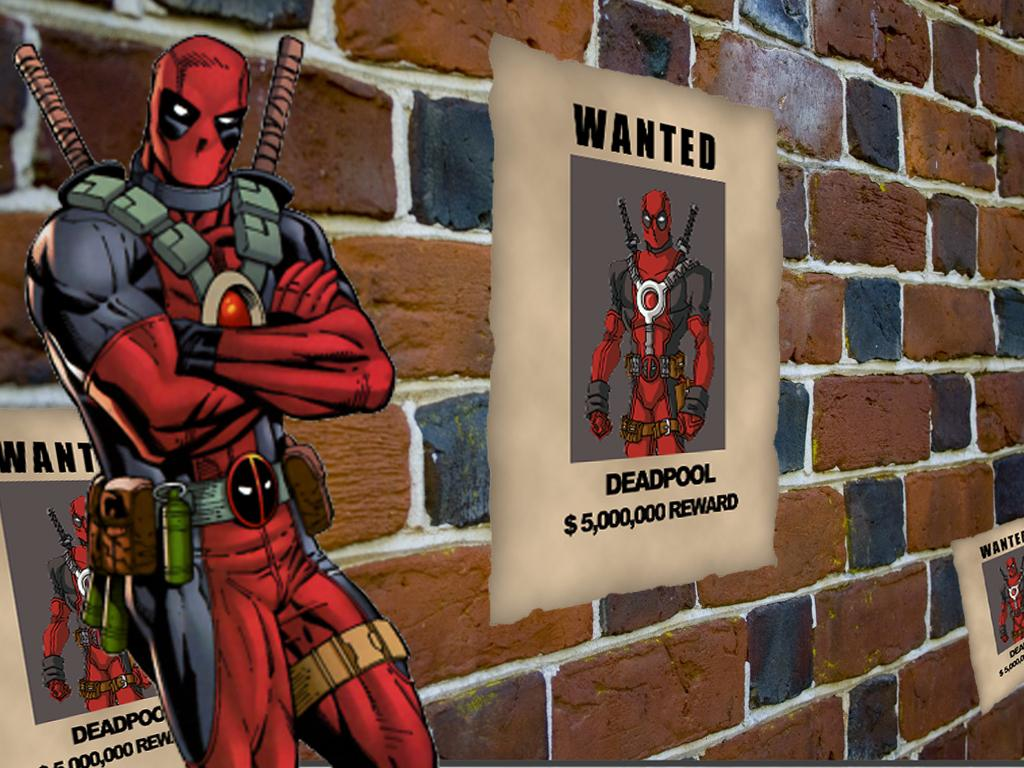<image>
Describe the image concisely. Poster on a wall that says "Wanted Deadpool" with the reward at 5 million. 